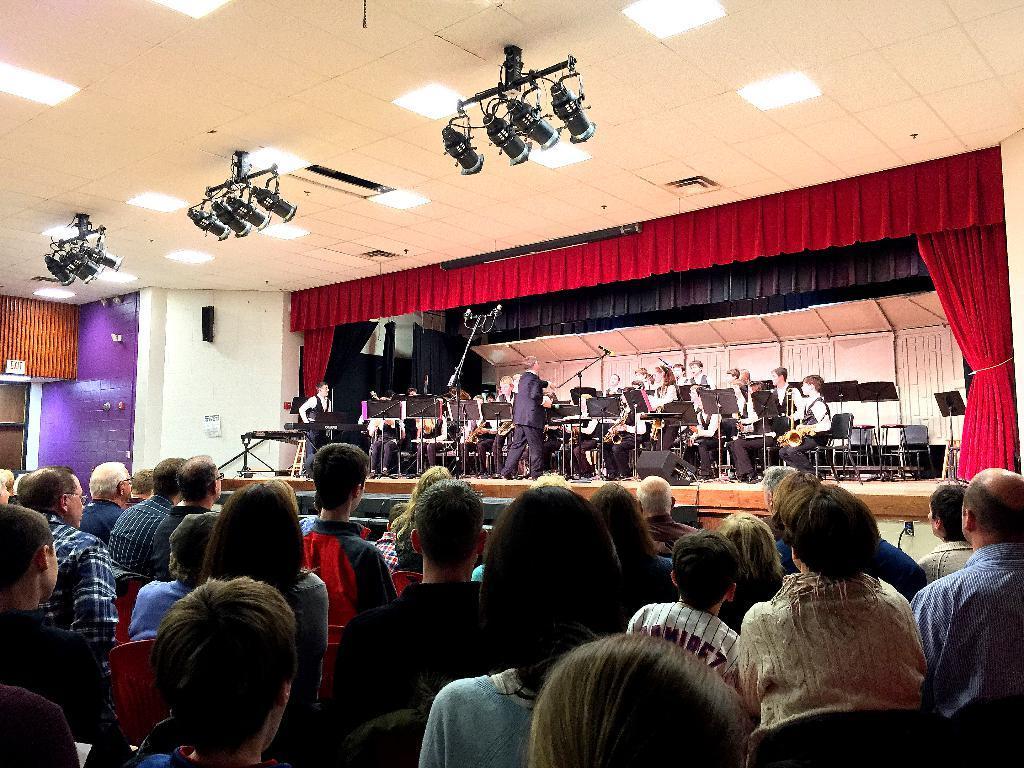How would you summarize this image in a sentence or two? It looks like an auditorium, a group of people are standing and observing this programme, here few people are sitting few of them are standing performing the musical actions. At the top these are the lights to the roof. 